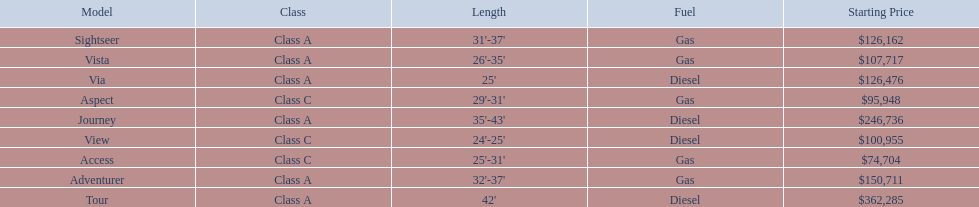Which models are manufactured by winnebago industries? Tour, Journey, Adventurer, Via, Sightseer, Vista, View, Aspect, Access. What type of fuel does each model require? Diesel, Diesel, Gas, Diesel, Gas, Gas, Diesel, Gas, Gas. And between the tour and aspect, which runs on diesel? Tour. 